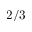<formula> <loc_0><loc_0><loc_500><loc_500>2 / 3</formula> 